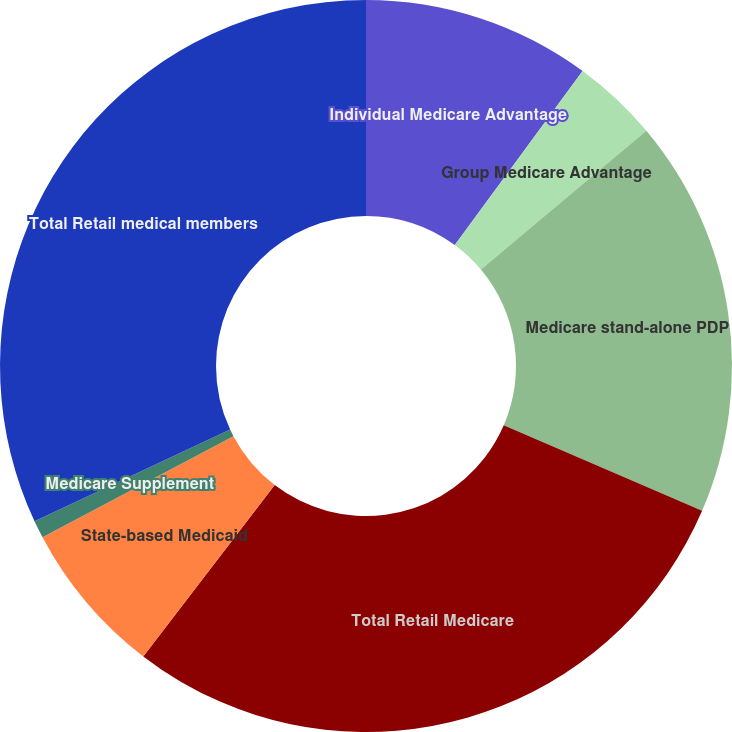Convert chart. <chart><loc_0><loc_0><loc_500><loc_500><pie_chart><fcel>Individual Medicare Advantage<fcel>Group Medicare Advantage<fcel>Medicare stand-alone PDP<fcel>Total Retail Medicare<fcel>State-based Medicaid<fcel>Medicare Supplement<fcel>Total Retail medical members<nl><fcel>10.08%<fcel>3.81%<fcel>17.59%<fcel>28.94%<fcel>6.84%<fcel>0.78%<fcel>31.97%<nl></chart> 